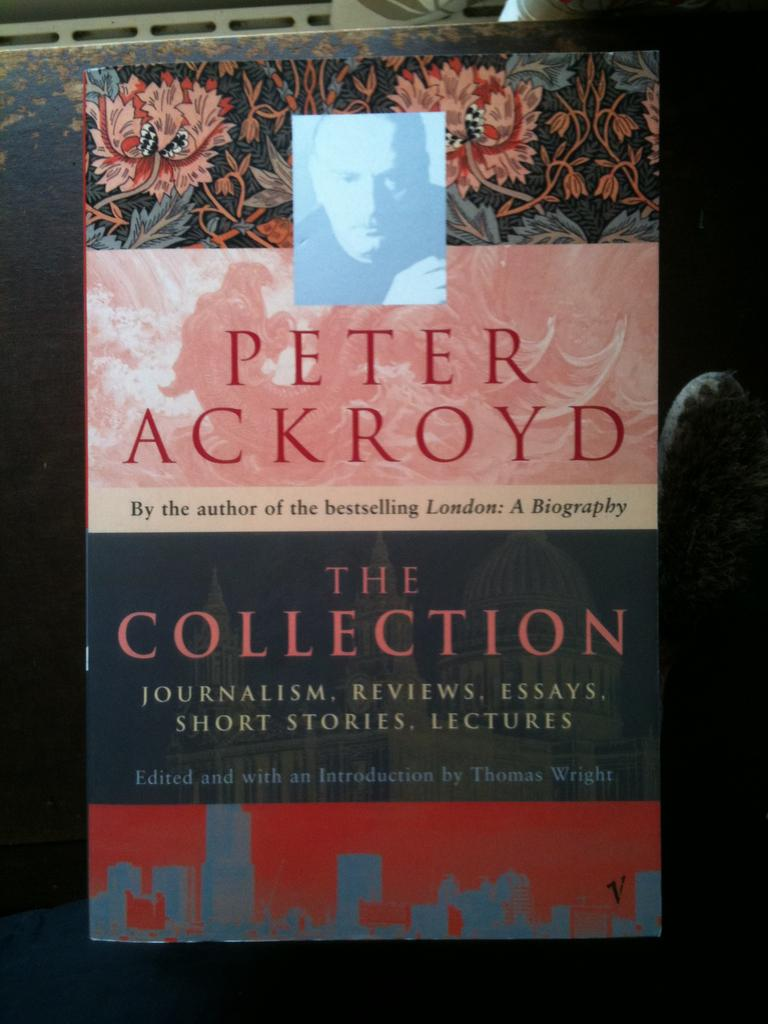What is on the gate in the image? There is a poster on the gate in the image. What can be seen at the top of the image? Focus lights are visible at the top of the image, and there is also an object present. Can you describe the person's face in the image? A person's face is present in the image. What type of throat is visible in the image? There is no throat present in the image. Is the roof of the building visible in the image? The provided facts do not mention a roof, so it cannot be determined if it is visible in the image. 